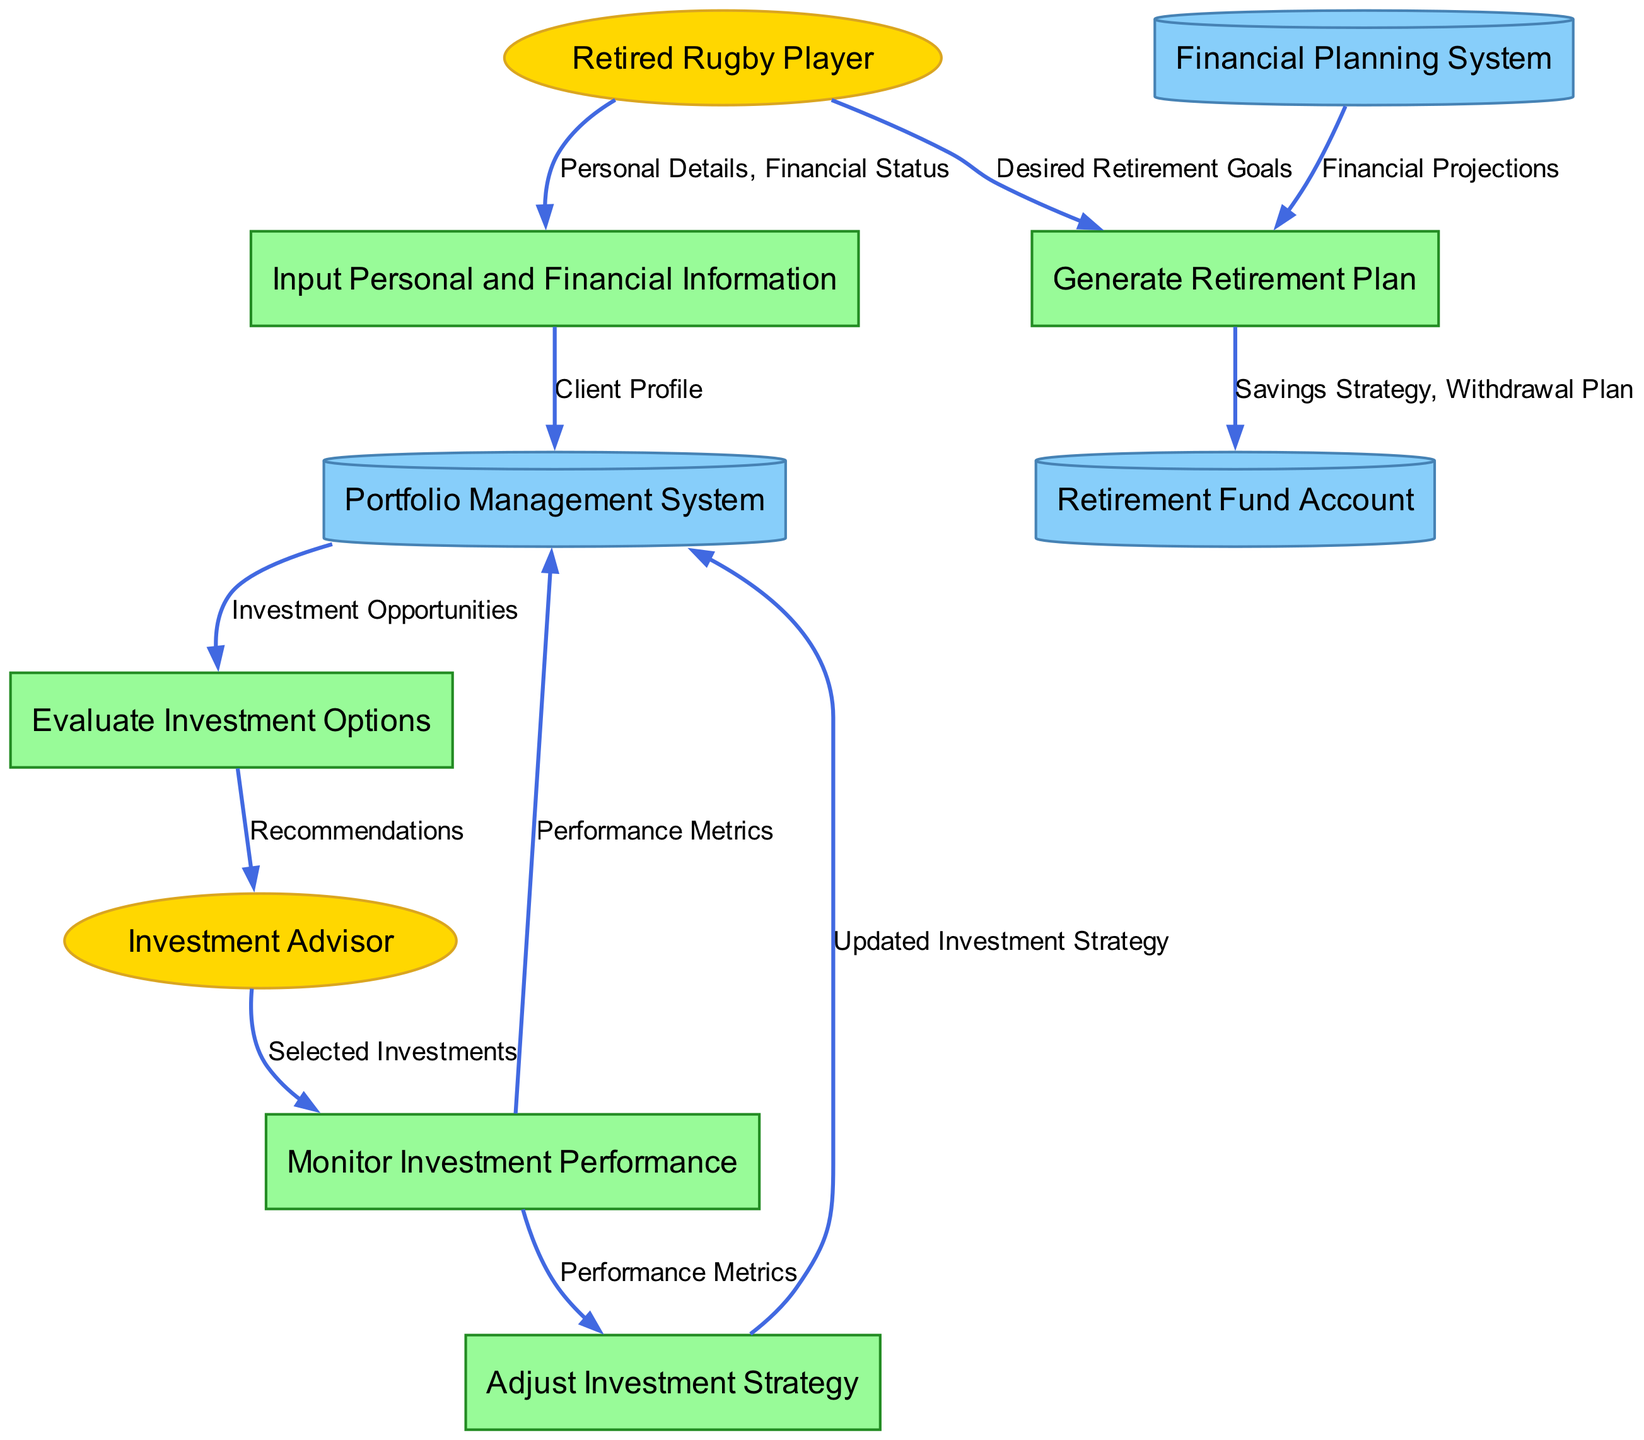What is the primary external entity in the diagram? The primary external entity in the diagram is the "Retired Rugby Player," which initiates the process by providing personal and financial information.
Answer: Retired Rugby Player How many data stores are present in the diagram? The diagram contains three data stores: "Portfolio Management System," "Financial Planning System," and "Retirement Fund Account."
Answer: 3 What data does the "Input Personal and Financial Information" process receive? The process "Input Personal and Financial Information" receives "Personal Details" and "Financial Status" from the "Retired Rugby Player."
Answer: Personal Details, Financial Status  The "Generate Retirement Plan" process outputs the "Savings Strategy" and "Withdrawal Plan" to the "Retirement Fund Account."
Answer: Generate Retirement Plan What is the source of the "Performance Metrics" that are sent to the "Portfolio Management System"? The "Performance Metrics" sent to the "Portfolio Management System" come from the "Monitor Investment Performance" process.
Answer: Monitor Investment Performance Which process provides "Recommendations" to the "Investment Advisor"? The process "Evaluate Investment Options" provides "Recommendations" to the "Investment Advisor."
Answer: Evaluate Investment Options How many processes are there in total in the diagram? The diagram has five processes: "Input Personal and Financial Information," "Evaluate Investment Options," "Monitor Investment Performance," "Adjust Investment Strategy," and "Generate Retirement Plan."
Answer: 5 What data flows from the "Investment Advisor" to "Monitor Investment Performance"? The data that flows from the "Investment Advisor" to "Monitor Investment Performance" is "Selected Investments."
Answer: Selected Investments What does the "Adjust Investment Strategy" process receive as input? The "Adjust Investment Strategy" process receives "Performance Metrics" as input from the "Monitor Investment Performance" process.
Answer: Performance Metrics 